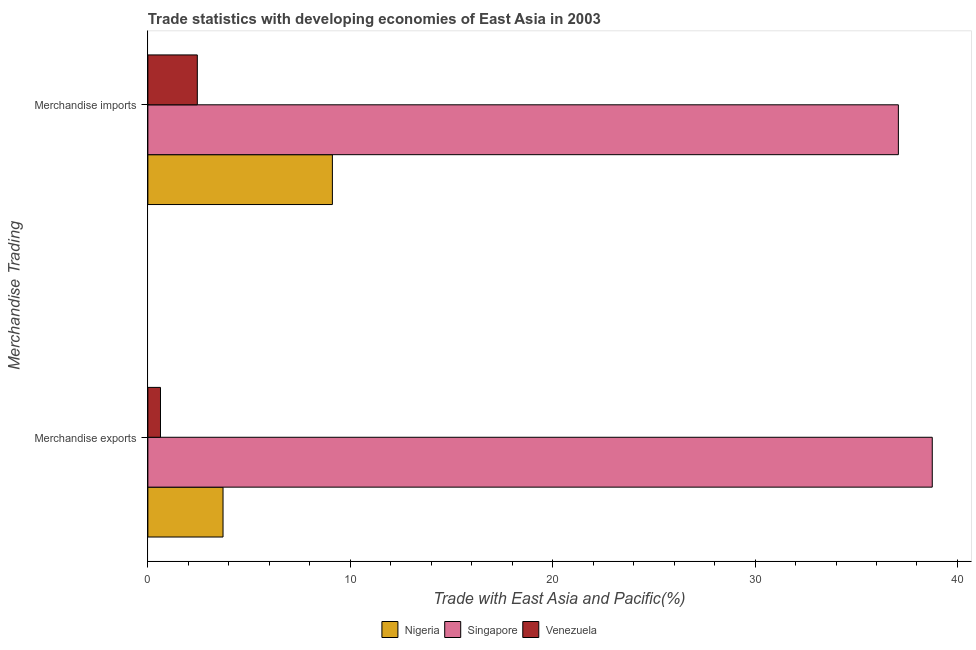How many different coloured bars are there?
Provide a succinct answer. 3. Are the number of bars on each tick of the Y-axis equal?
Offer a very short reply. Yes. How many bars are there on the 2nd tick from the bottom?
Offer a very short reply. 3. What is the merchandise exports in Nigeria?
Offer a very short reply. 3.71. Across all countries, what is the maximum merchandise exports?
Ensure brevity in your answer.  38.76. Across all countries, what is the minimum merchandise exports?
Provide a succinct answer. 0.62. In which country was the merchandise imports maximum?
Offer a terse response. Singapore. In which country was the merchandise exports minimum?
Offer a terse response. Venezuela. What is the total merchandise imports in the graph?
Provide a short and direct response. 48.64. What is the difference between the merchandise exports in Singapore and that in Venezuela?
Offer a very short reply. 38.13. What is the difference between the merchandise exports in Venezuela and the merchandise imports in Nigeria?
Your answer should be compact. -8.49. What is the average merchandise exports per country?
Offer a terse response. 14.36. What is the difference between the merchandise exports and merchandise imports in Nigeria?
Provide a succinct answer. -5.4. In how many countries, is the merchandise exports greater than 38 %?
Provide a succinct answer. 1. What is the ratio of the merchandise exports in Venezuela to that in Nigeria?
Your response must be concise. 0.17. What does the 1st bar from the top in Merchandise imports represents?
Provide a short and direct response. Venezuela. What does the 2nd bar from the bottom in Merchandise exports represents?
Make the answer very short. Singapore. Are all the bars in the graph horizontal?
Provide a succinct answer. Yes. How many countries are there in the graph?
Provide a short and direct response. 3. Does the graph contain grids?
Ensure brevity in your answer.  No. How many legend labels are there?
Offer a very short reply. 3. What is the title of the graph?
Ensure brevity in your answer.  Trade statistics with developing economies of East Asia in 2003. Does "China" appear as one of the legend labels in the graph?
Provide a short and direct response. No. What is the label or title of the X-axis?
Provide a short and direct response. Trade with East Asia and Pacific(%). What is the label or title of the Y-axis?
Keep it short and to the point. Merchandise Trading. What is the Trade with East Asia and Pacific(%) in Nigeria in Merchandise exports?
Offer a very short reply. 3.71. What is the Trade with East Asia and Pacific(%) in Singapore in Merchandise exports?
Keep it short and to the point. 38.76. What is the Trade with East Asia and Pacific(%) in Venezuela in Merchandise exports?
Your answer should be very brief. 0.62. What is the Trade with East Asia and Pacific(%) of Nigeria in Merchandise imports?
Provide a short and direct response. 9.12. What is the Trade with East Asia and Pacific(%) in Singapore in Merchandise imports?
Offer a terse response. 37.08. What is the Trade with East Asia and Pacific(%) in Venezuela in Merchandise imports?
Your answer should be compact. 2.44. Across all Merchandise Trading, what is the maximum Trade with East Asia and Pacific(%) in Nigeria?
Your answer should be compact. 9.12. Across all Merchandise Trading, what is the maximum Trade with East Asia and Pacific(%) of Singapore?
Make the answer very short. 38.76. Across all Merchandise Trading, what is the maximum Trade with East Asia and Pacific(%) of Venezuela?
Give a very brief answer. 2.44. Across all Merchandise Trading, what is the minimum Trade with East Asia and Pacific(%) in Nigeria?
Your answer should be compact. 3.71. Across all Merchandise Trading, what is the minimum Trade with East Asia and Pacific(%) in Singapore?
Offer a very short reply. 37.08. Across all Merchandise Trading, what is the minimum Trade with East Asia and Pacific(%) of Venezuela?
Your response must be concise. 0.62. What is the total Trade with East Asia and Pacific(%) of Nigeria in the graph?
Make the answer very short. 12.83. What is the total Trade with East Asia and Pacific(%) of Singapore in the graph?
Keep it short and to the point. 75.84. What is the total Trade with East Asia and Pacific(%) in Venezuela in the graph?
Give a very brief answer. 3.07. What is the difference between the Trade with East Asia and Pacific(%) in Nigeria in Merchandise exports and that in Merchandise imports?
Provide a succinct answer. -5.4. What is the difference between the Trade with East Asia and Pacific(%) of Singapore in Merchandise exports and that in Merchandise imports?
Offer a terse response. 1.67. What is the difference between the Trade with East Asia and Pacific(%) of Venezuela in Merchandise exports and that in Merchandise imports?
Offer a terse response. -1.82. What is the difference between the Trade with East Asia and Pacific(%) in Nigeria in Merchandise exports and the Trade with East Asia and Pacific(%) in Singapore in Merchandise imports?
Ensure brevity in your answer.  -33.37. What is the difference between the Trade with East Asia and Pacific(%) of Nigeria in Merchandise exports and the Trade with East Asia and Pacific(%) of Venezuela in Merchandise imports?
Your answer should be compact. 1.27. What is the difference between the Trade with East Asia and Pacific(%) of Singapore in Merchandise exports and the Trade with East Asia and Pacific(%) of Venezuela in Merchandise imports?
Provide a succinct answer. 36.31. What is the average Trade with East Asia and Pacific(%) in Nigeria per Merchandise Trading?
Your answer should be compact. 6.42. What is the average Trade with East Asia and Pacific(%) in Singapore per Merchandise Trading?
Offer a very short reply. 37.92. What is the average Trade with East Asia and Pacific(%) in Venezuela per Merchandise Trading?
Your answer should be very brief. 1.53. What is the difference between the Trade with East Asia and Pacific(%) of Nigeria and Trade with East Asia and Pacific(%) of Singapore in Merchandise exports?
Provide a succinct answer. -35.04. What is the difference between the Trade with East Asia and Pacific(%) of Nigeria and Trade with East Asia and Pacific(%) of Venezuela in Merchandise exports?
Offer a terse response. 3.09. What is the difference between the Trade with East Asia and Pacific(%) of Singapore and Trade with East Asia and Pacific(%) of Venezuela in Merchandise exports?
Your answer should be compact. 38.13. What is the difference between the Trade with East Asia and Pacific(%) in Nigeria and Trade with East Asia and Pacific(%) in Singapore in Merchandise imports?
Offer a terse response. -27.96. What is the difference between the Trade with East Asia and Pacific(%) in Nigeria and Trade with East Asia and Pacific(%) in Venezuela in Merchandise imports?
Make the answer very short. 6.67. What is the difference between the Trade with East Asia and Pacific(%) of Singapore and Trade with East Asia and Pacific(%) of Venezuela in Merchandise imports?
Give a very brief answer. 34.64. What is the ratio of the Trade with East Asia and Pacific(%) of Nigeria in Merchandise exports to that in Merchandise imports?
Give a very brief answer. 0.41. What is the ratio of the Trade with East Asia and Pacific(%) of Singapore in Merchandise exports to that in Merchandise imports?
Provide a short and direct response. 1.05. What is the ratio of the Trade with East Asia and Pacific(%) in Venezuela in Merchandise exports to that in Merchandise imports?
Your answer should be compact. 0.26. What is the difference between the highest and the second highest Trade with East Asia and Pacific(%) in Nigeria?
Your answer should be very brief. 5.4. What is the difference between the highest and the second highest Trade with East Asia and Pacific(%) of Singapore?
Give a very brief answer. 1.67. What is the difference between the highest and the second highest Trade with East Asia and Pacific(%) in Venezuela?
Your response must be concise. 1.82. What is the difference between the highest and the lowest Trade with East Asia and Pacific(%) of Nigeria?
Your answer should be very brief. 5.4. What is the difference between the highest and the lowest Trade with East Asia and Pacific(%) in Singapore?
Keep it short and to the point. 1.67. What is the difference between the highest and the lowest Trade with East Asia and Pacific(%) in Venezuela?
Provide a short and direct response. 1.82. 